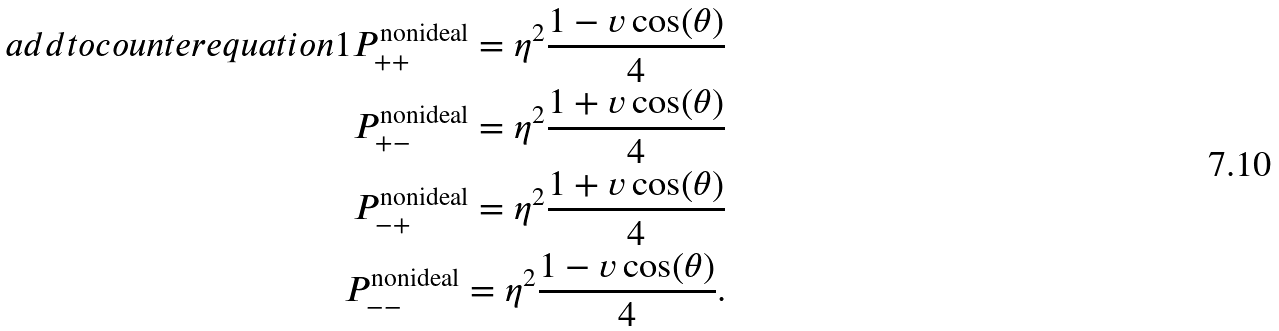Convert formula to latex. <formula><loc_0><loc_0><loc_500><loc_500>\ a d d t o c o u n t e r { e q u a t i o n } { 1 } P ^ { \text {nonideal} } _ { + + } = \eta ^ { 2 } \frac { 1 - v \cos ( \theta ) } 4 \\ P ^ { \text {nonideal} } _ { + - } = \eta ^ { 2 } \frac { 1 + v \cos ( \theta ) } 4 \\ P ^ { \text {nonideal} } _ { - + } = \eta ^ { 2 } \frac { 1 + v \cos ( \theta ) } 4 \\ P ^ { \text {nonideal} } _ { - - } = \eta ^ { 2 } \frac { 1 - v \cos ( \theta ) } 4 .</formula> 